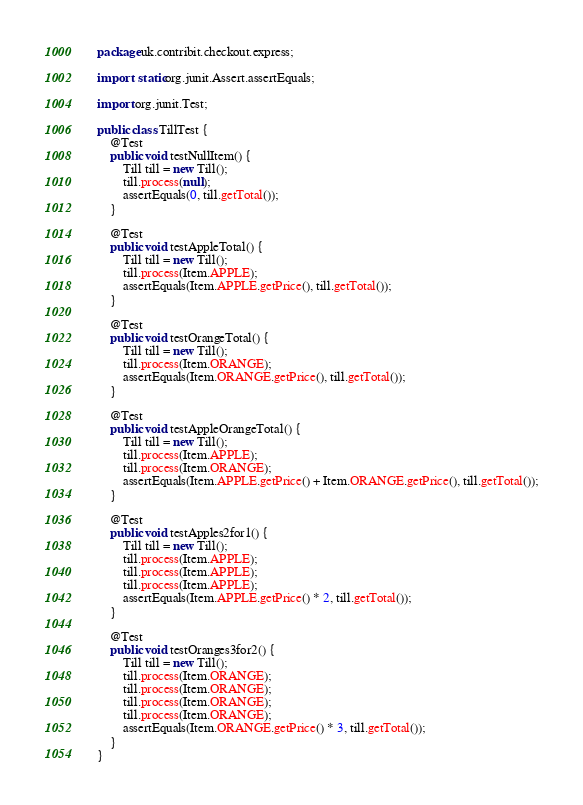<code> <loc_0><loc_0><loc_500><loc_500><_Java_>package uk.contribit.checkout.express;

import static org.junit.Assert.assertEquals;

import org.junit.Test;

public class TillTest {
    @Test
    public void testNullItem() {
        Till till = new Till();
        till.process(null);
        assertEquals(0, till.getTotal());
    }

    @Test
    public void testAppleTotal() {
        Till till = new Till();
        till.process(Item.APPLE);
        assertEquals(Item.APPLE.getPrice(), till.getTotal());
    }

    @Test
    public void testOrangeTotal() {
        Till till = new Till();
        till.process(Item.ORANGE);
        assertEquals(Item.ORANGE.getPrice(), till.getTotal());
    }

    @Test
    public void testAppleOrangeTotal() {
        Till till = new Till();
        till.process(Item.APPLE);
        till.process(Item.ORANGE);
        assertEquals(Item.APPLE.getPrice() + Item.ORANGE.getPrice(), till.getTotal());
    }

    @Test
    public void testApples2for1() {
        Till till = new Till();
        till.process(Item.APPLE);
        till.process(Item.APPLE);
        till.process(Item.APPLE);
        assertEquals(Item.APPLE.getPrice() * 2, till.getTotal());
    }

    @Test
    public void testOranges3for2() {
        Till till = new Till();
        till.process(Item.ORANGE);
        till.process(Item.ORANGE);
        till.process(Item.ORANGE);
        till.process(Item.ORANGE);
        assertEquals(Item.ORANGE.getPrice() * 3, till.getTotal());
    }
}
</code> 